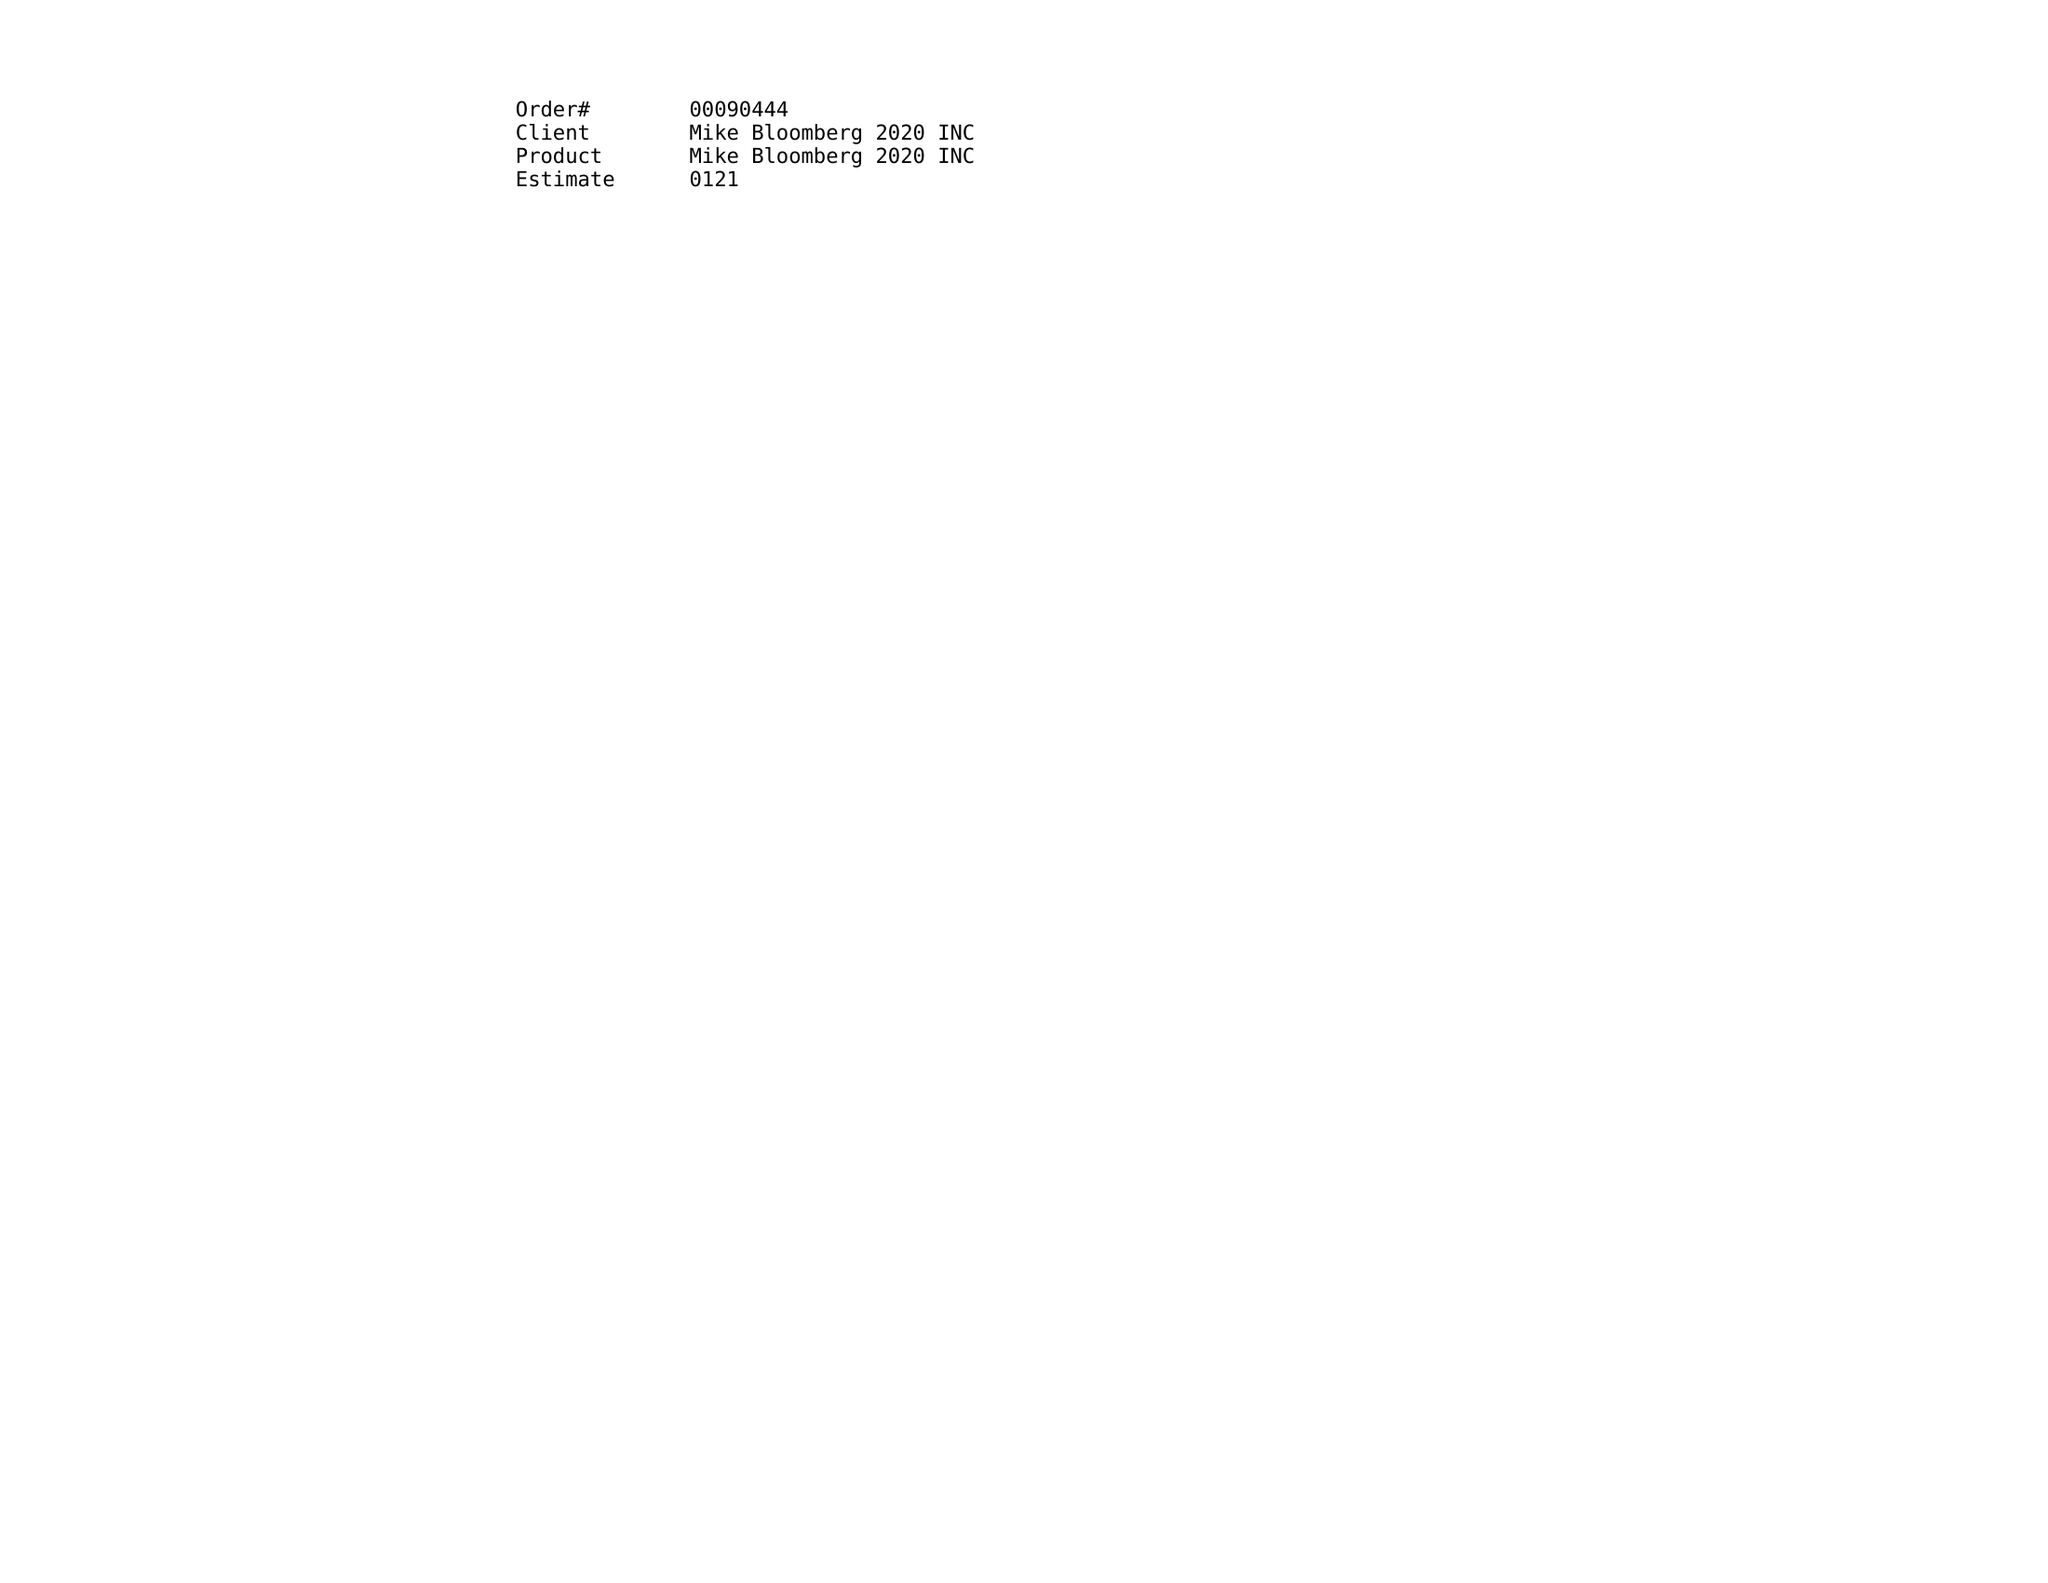What is the value for the gross_amount?
Answer the question using a single word or phrase. 158570.00 